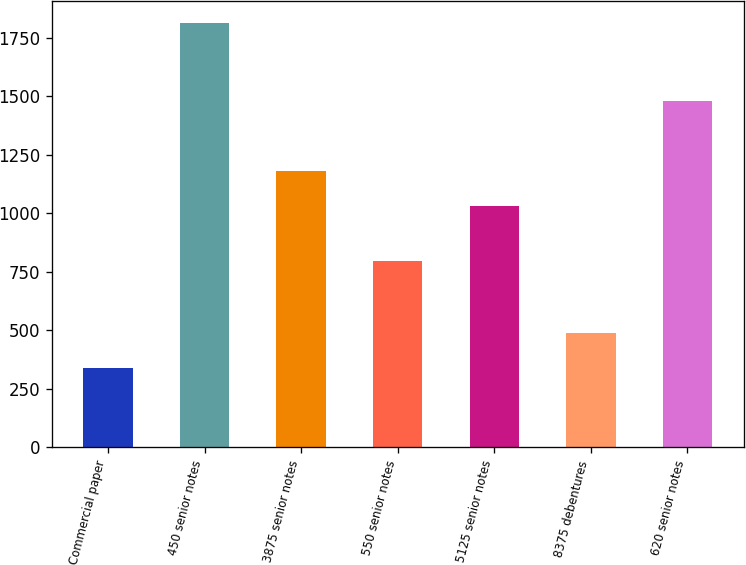Convert chart to OTSL. <chart><loc_0><loc_0><loc_500><loc_500><bar_chart><fcel>Commercial paper<fcel>450 senior notes<fcel>3875 senior notes<fcel>550 senior notes<fcel>5125 senior notes<fcel>8375 debentures<fcel>620 senior notes<nl><fcel>341<fcel>1815<fcel>1179.4<fcel>795<fcel>1032<fcel>488.4<fcel>1480<nl></chart> 